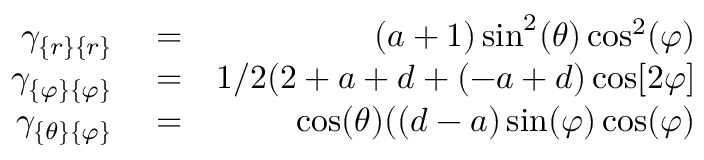<formula> <loc_0><loc_0><loc_500><loc_500>\begin{array} { r l r } { \gamma _ { \{ r \} \{ r \} } } & = } & { ( a + 1 ) \sin ^ { 2 } ( \theta ) \cos ^ { 2 } ( \varphi ) } \\ { \gamma _ { \{ \varphi \} \{ \varphi \} } } & = } & { 1 / 2 ( 2 + a + d + ( - a + d ) \cos [ 2 \varphi ] } \\ { \gamma _ { \{ \theta \} \{ \varphi \} } } & = } & { \cos ( \theta ) ( ( d - a ) \sin ( \varphi ) \cos ( \varphi ) } \end{array}</formula> 